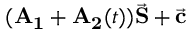<formula> <loc_0><loc_0><loc_500><loc_500>( A _ { 1 } + A _ { 2 } ( t ) ) \vec { S } + \vec { c }</formula> 